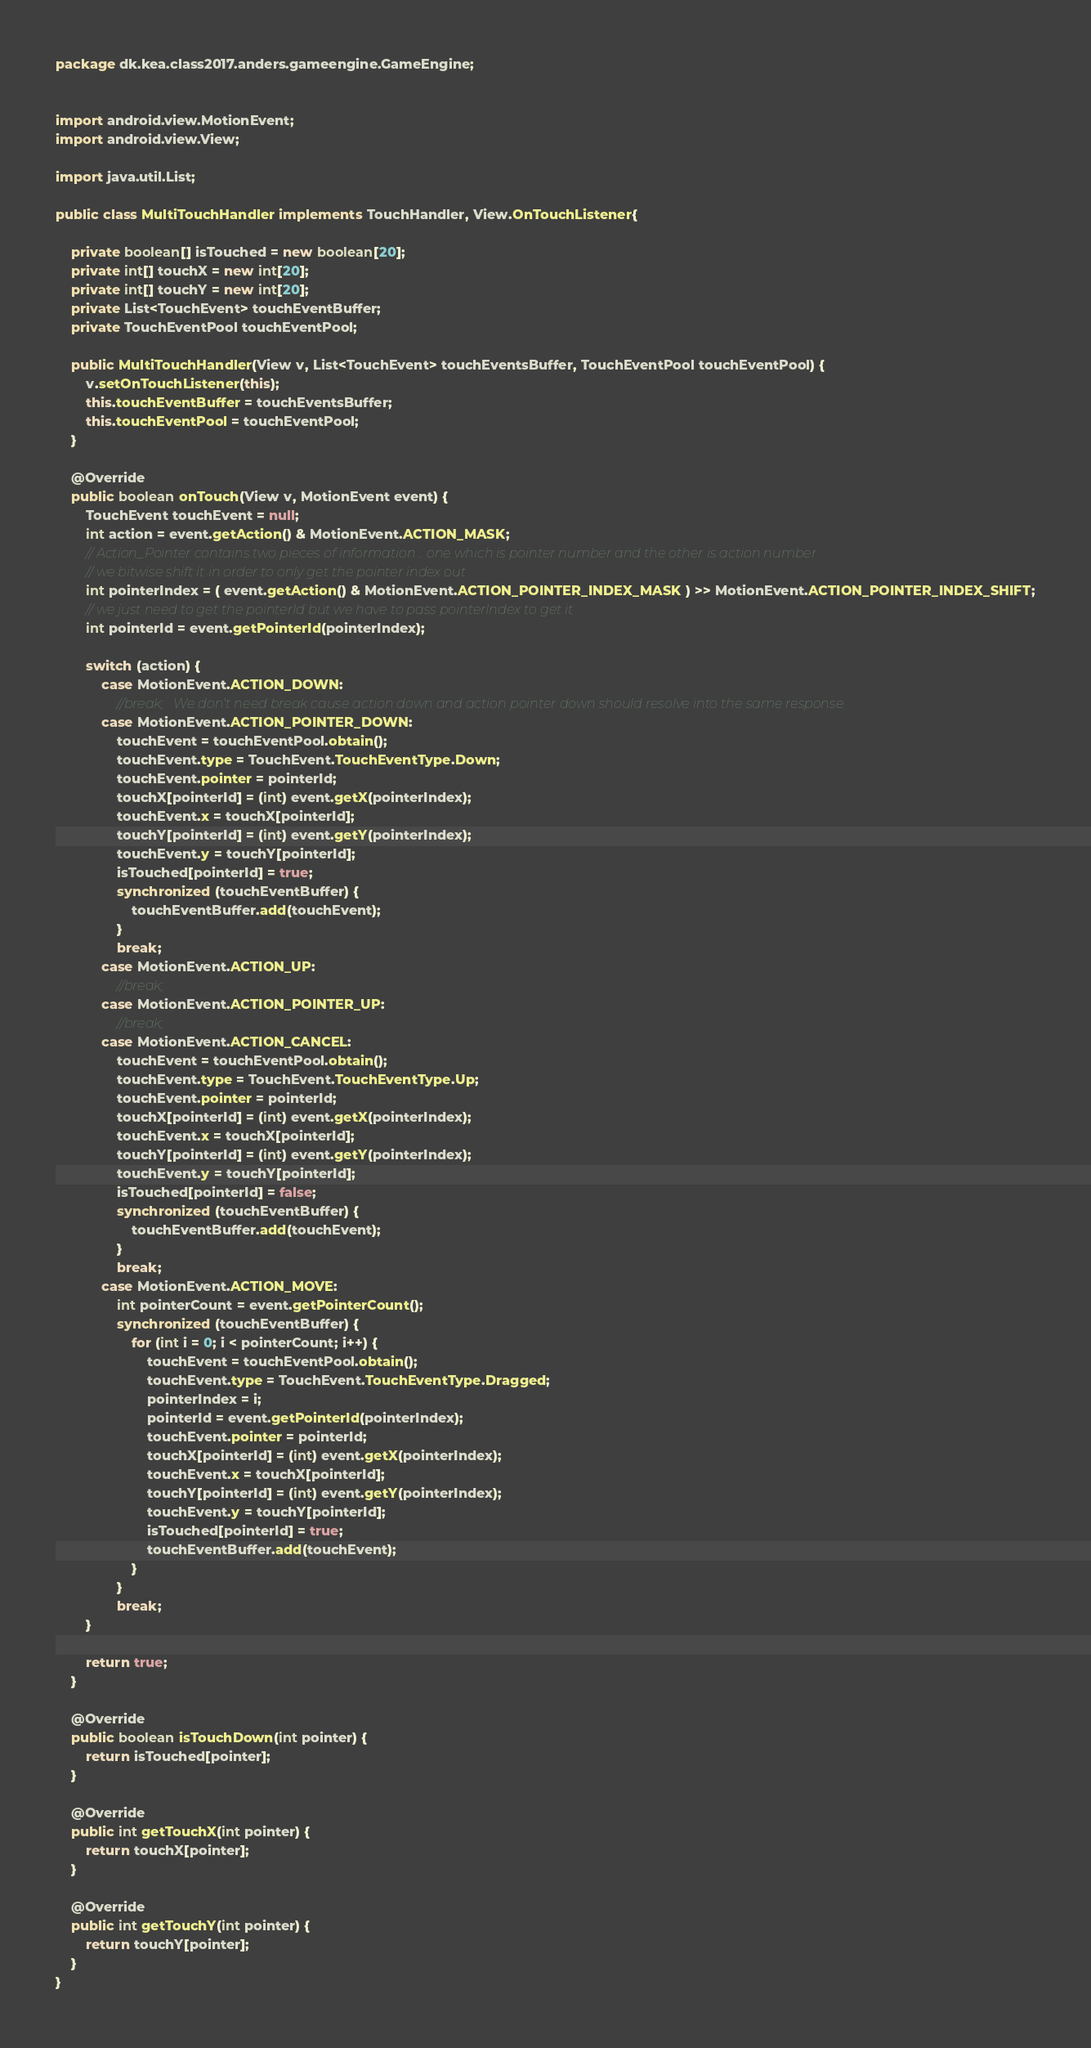<code> <loc_0><loc_0><loc_500><loc_500><_Java_>package dk.kea.class2017.anders.gameengine.GameEngine;


import android.view.MotionEvent;
import android.view.View;

import java.util.List;

public class MultiTouchHandler implements TouchHandler, View.OnTouchListener{

    private boolean[] isTouched = new boolean[20];
    private int[] touchX = new int[20];
    private int[] touchY = new int[20];
    private List<TouchEvent> touchEventBuffer;
    private TouchEventPool touchEventPool;

    public MultiTouchHandler(View v, List<TouchEvent> touchEventsBuffer, TouchEventPool touchEventPool) {
        v.setOnTouchListener(this);
        this.touchEventBuffer = touchEventsBuffer;
        this.touchEventPool = touchEventPool;
    }

    @Override
    public boolean onTouch(View v, MotionEvent event) {
        TouchEvent touchEvent = null;
        int action = event.getAction() & MotionEvent.ACTION_MASK;
        // Action_Pointer contains two pieces of information .. one which is pointer number and the other is action number
        // we bitwise shift it in order to only get the pointer index out
        int pointerIndex = ( event.getAction() & MotionEvent.ACTION_POINTER_INDEX_MASK ) >> MotionEvent.ACTION_POINTER_INDEX_SHIFT;
        // we just need to get the pointerId but we have to pass pointerIndex to get it
        int pointerId = event.getPointerId(pointerIndex);

        switch (action) {
            case MotionEvent.ACTION_DOWN:
                //break;   We don't need break cause action down and action pointer down should resolve into the same response
            case MotionEvent.ACTION_POINTER_DOWN:
                touchEvent = touchEventPool.obtain();
                touchEvent.type = TouchEvent.TouchEventType.Down;
                touchEvent.pointer = pointerId;
                touchX[pointerId] = (int) event.getX(pointerIndex);
                touchEvent.x = touchX[pointerId];
                touchY[pointerId] = (int) event.getY(pointerIndex);
                touchEvent.y = touchY[pointerId];
                isTouched[pointerId] = true;
                synchronized (touchEventBuffer) {
                    touchEventBuffer.add(touchEvent);
                }
                break;
            case MotionEvent.ACTION_UP:
                //break;
            case MotionEvent.ACTION_POINTER_UP:
                //break;
            case MotionEvent.ACTION_CANCEL:
                touchEvent = touchEventPool.obtain();
                touchEvent.type = TouchEvent.TouchEventType.Up;
                touchEvent.pointer = pointerId;
                touchX[pointerId] = (int) event.getX(pointerIndex);
                touchEvent.x = touchX[pointerId];
                touchY[pointerId] = (int) event.getY(pointerIndex);
                touchEvent.y = touchY[pointerId];
                isTouched[pointerId] = false;
                synchronized (touchEventBuffer) {
                    touchEventBuffer.add(touchEvent);
                }
                break;
            case MotionEvent.ACTION_MOVE:
                int pointerCount = event.getPointerCount();
                synchronized (touchEventBuffer) {
                    for (int i = 0; i < pointerCount; i++) {
                        touchEvent = touchEventPool.obtain();
                        touchEvent.type = TouchEvent.TouchEventType.Dragged;
                        pointerIndex = i;
                        pointerId = event.getPointerId(pointerIndex);
                        touchEvent.pointer = pointerId;
                        touchX[pointerId] = (int) event.getX(pointerIndex);
                        touchEvent.x = touchX[pointerId];
                        touchY[pointerId] = (int) event.getY(pointerIndex);
                        touchEvent.y = touchY[pointerId];
                        isTouched[pointerId] = true;
                        touchEventBuffer.add(touchEvent);
                    }
                }
                break;
        }

        return true;
    }

    @Override
    public boolean isTouchDown(int pointer) {
        return isTouched[pointer];
    }

    @Override
    public int getTouchX(int pointer) {
        return touchX[pointer];
    }

    @Override
    public int getTouchY(int pointer) {
        return touchY[pointer];
    }
}
</code> 